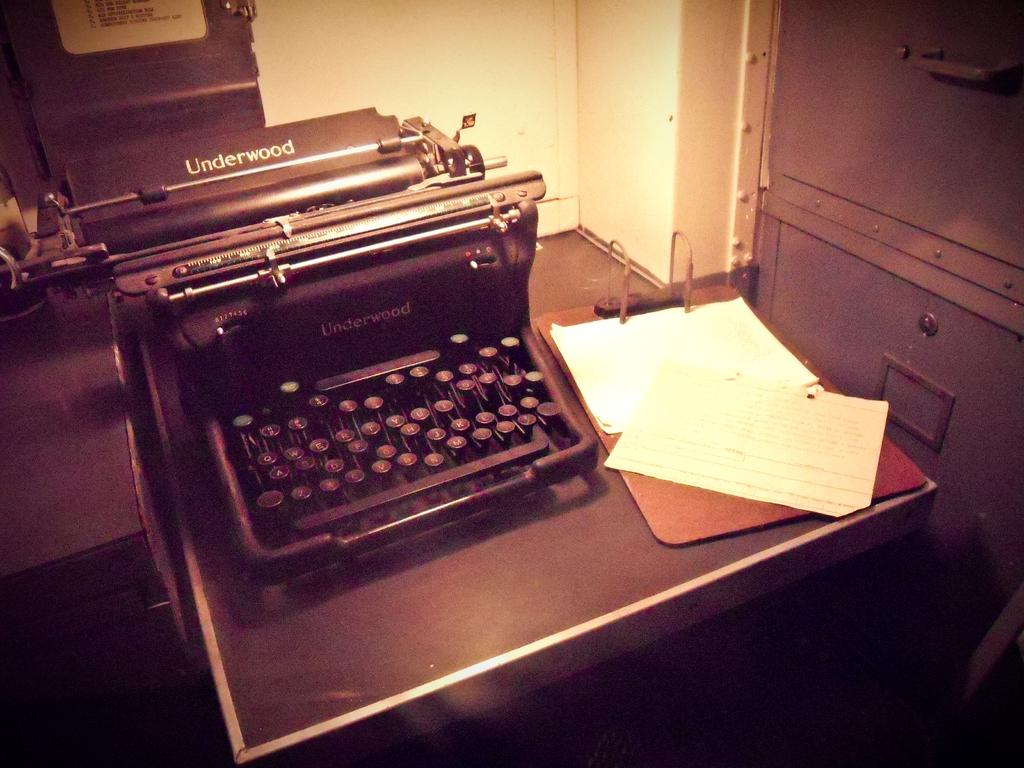<image>
Write a terse but informative summary of the picture. An old underwood typewriter is sitting on a desk beside a file cabinet. 